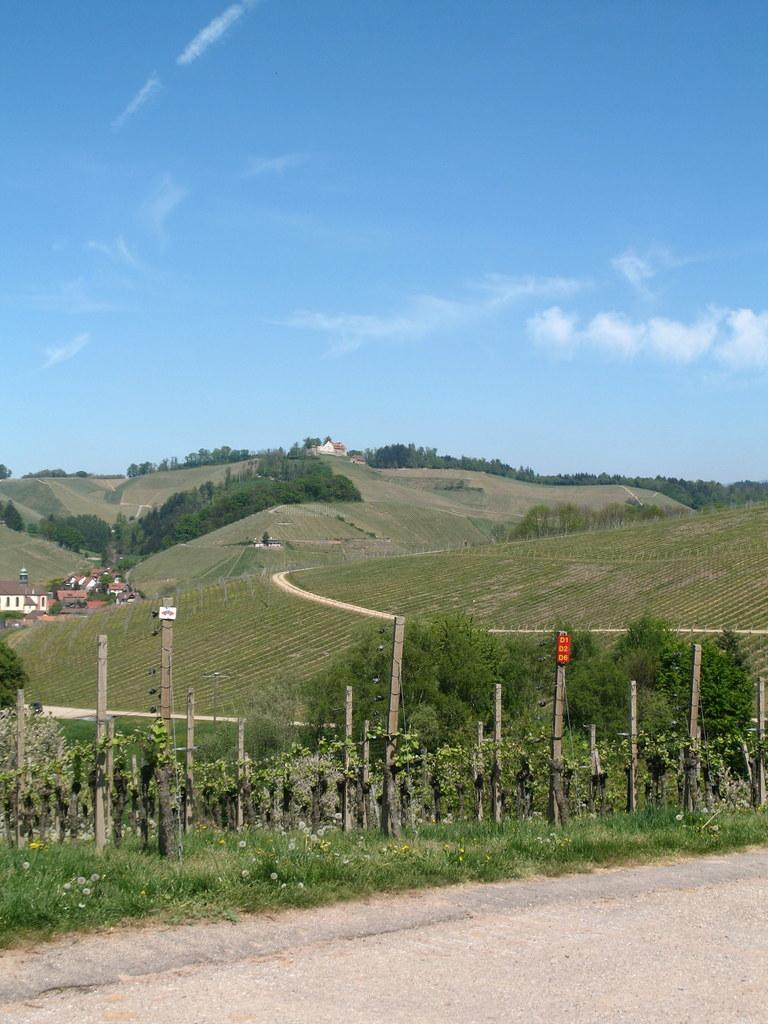What type of structure is present in the image? There is a building in the image. What type of vegetation can be seen in the image? There is grass, trees, and a plant in the image. What is the material of the pole in the image? The pole in the image is made of wood. What is visible in the sky in the image? The sky is visible in the image. What type of pathway is present in the image? There is a road in the image. Can you describe the harmony between the clouds and the attack in the image? There are no clouds or attacks present in the image. The image features a building, grass, a wooden pole, trees, a plant, the sky, and a road. 